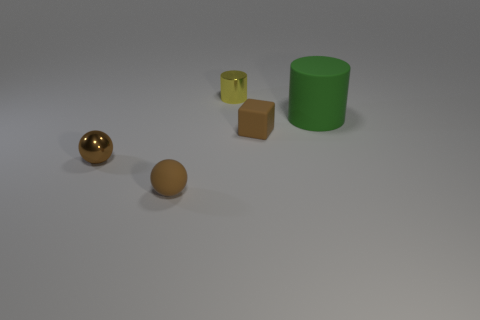Are there any other things that have the same size as the green object?
Give a very brief answer. No. What is the shape of the thing that is both behind the small brown block and on the left side of the large cylinder?
Your answer should be compact. Cylinder. There is a green rubber cylinder behind the shiny thing in front of the big green cylinder; what size is it?
Make the answer very short. Large. How many large green things have the same shape as the brown shiny object?
Your response must be concise. 0. Is the color of the metallic ball the same as the tiny block?
Your answer should be very brief. Yes. Is there a tiny metallic thing of the same color as the matte sphere?
Your response must be concise. Yes. Are the brown ball that is in front of the brown metal sphere and the cylinder behind the large thing made of the same material?
Ensure brevity in your answer.  No. What is the color of the big thing?
Your answer should be compact. Green. There is a metal thing that is on the right side of the brown thing that is left of the small brown matte thing in front of the brown metallic thing; how big is it?
Give a very brief answer. Small. What number of other objects are the same size as the brown matte sphere?
Provide a succinct answer. 3. 